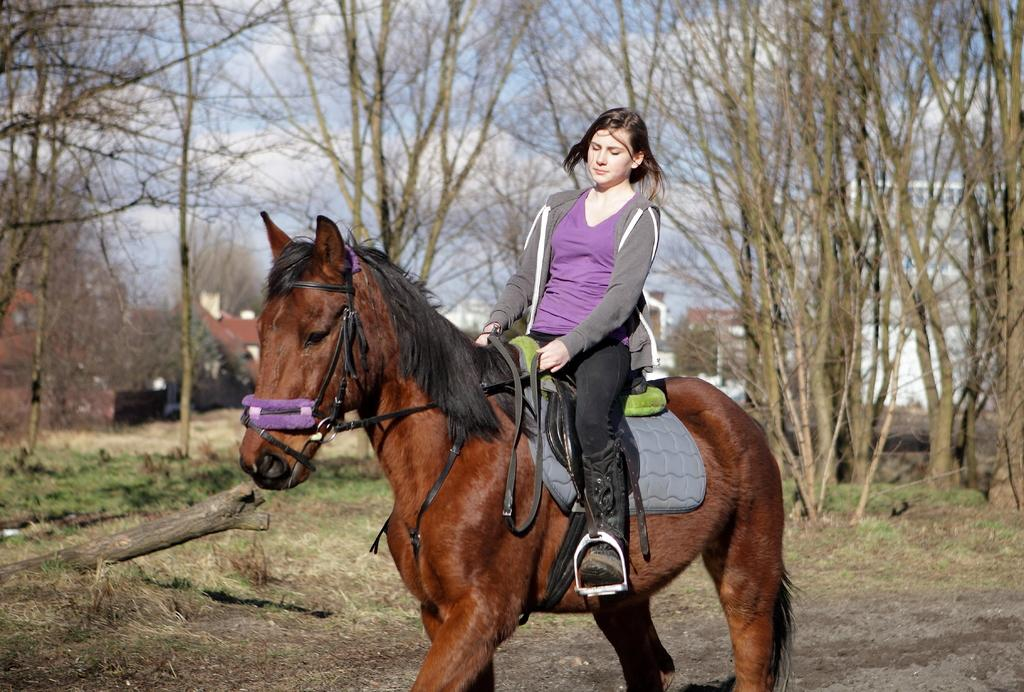Who is the main subject in the image? There is a girl in the image. What is the girl doing in the image? The girl is sitting on a horse. What can be seen in the background of the image? There are trees in the background of the image. How many babies are being transported in a drawer in the image? There are no babies or drawers present in the image. 